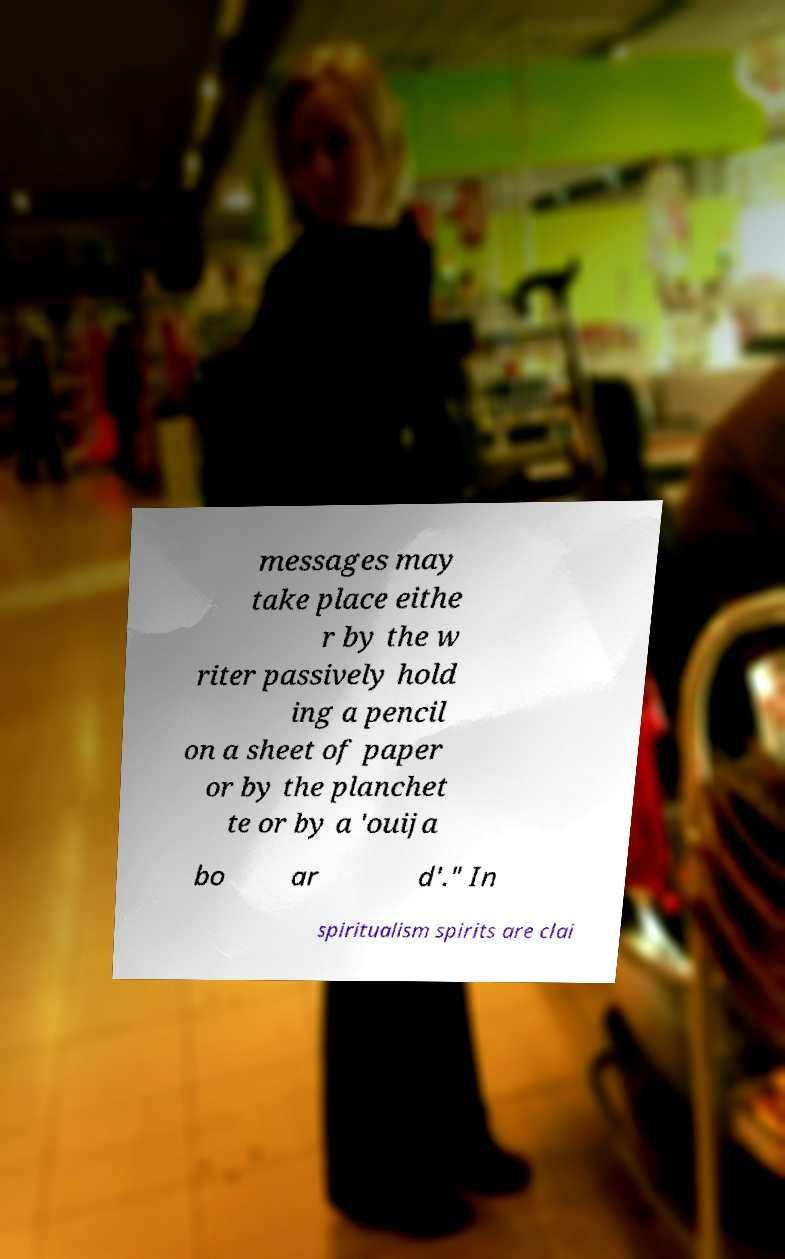There's text embedded in this image that I need extracted. Can you transcribe it verbatim? messages may take place eithe r by the w riter passively hold ing a pencil on a sheet of paper or by the planchet te or by a 'ouija bo ar d'." In spiritualism spirits are clai 